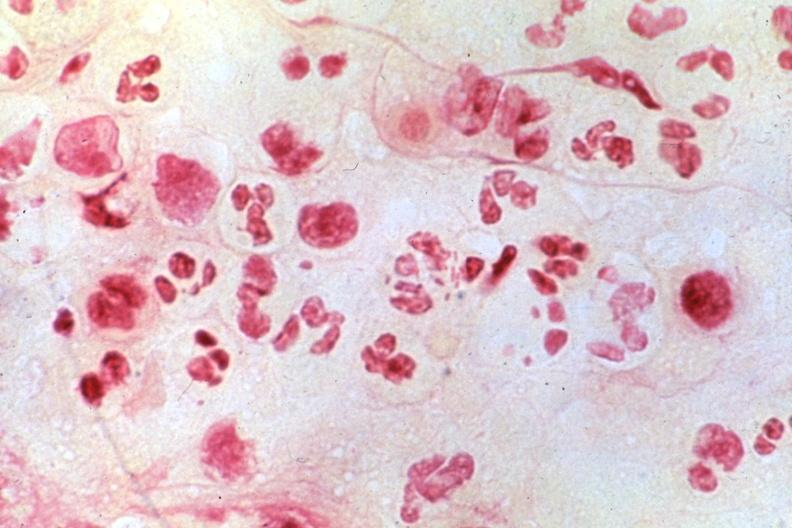does this image show chancroid, smear of bubo?
Answer the question using a single word or phrase. Yes 